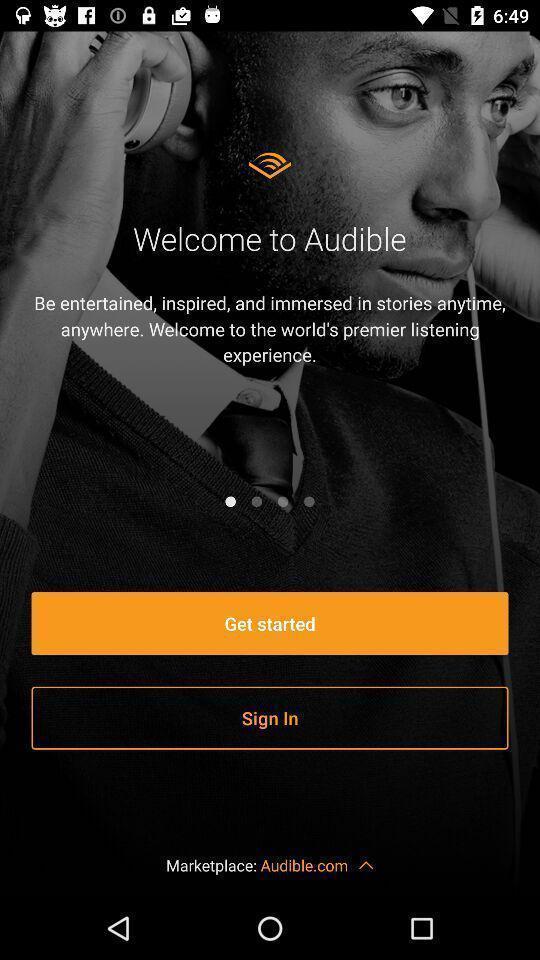What can you discern from this picture? Welcome page. 